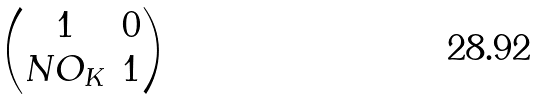<formula> <loc_0><loc_0><loc_500><loc_500>\begin{pmatrix} 1 & 0 \\ N O _ { K } & 1 \end{pmatrix}</formula> 